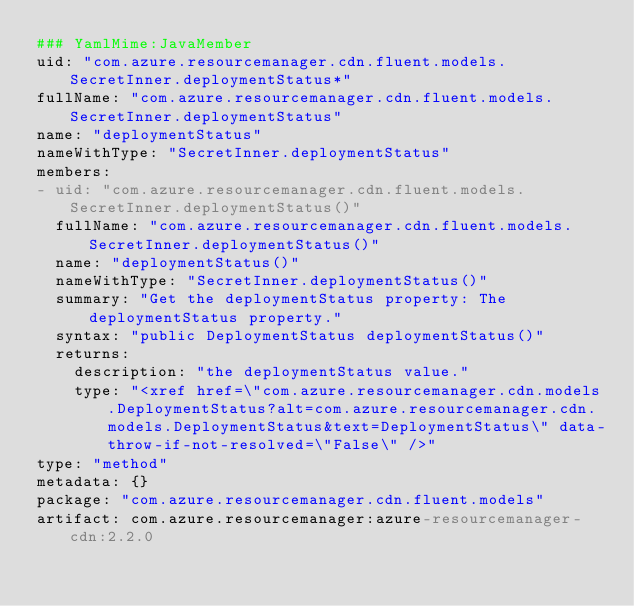<code> <loc_0><loc_0><loc_500><loc_500><_YAML_>### YamlMime:JavaMember
uid: "com.azure.resourcemanager.cdn.fluent.models.SecretInner.deploymentStatus*"
fullName: "com.azure.resourcemanager.cdn.fluent.models.SecretInner.deploymentStatus"
name: "deploymentStatus"
nameWithType: "SecretInner.deploymentStatus"
members:
- uid: "com.azure.resourcemanager.cdn.fluent.models.SecretInner.deploymentStatus()"
  fullName: "com.azure.resourcemanager.cdn.fluent.models.SecretInner.deploymentStatus()"
  name: "deploymentStatus()"
  nameWithType: "SecretInner.deploymentStatus()"
  summary: "Get the deploymentStatus property: The deploymentStatus property."
  syntax: "public DeploymentStatus deploymentStatus()"
  returns:
    description: "the deploymentStatus value."
    type: "<xref href=\"com.azure.resourcemanager.cdn.models.DeploymentStatus?alt=com.azure.resourcemanager.cdn.models.DeploymentStatus&text=DeploymentStatus\" data-throw-if-not-resolved=\"False\" />"
type: "method"
metadata: {}
package: "com.azure.resourcemanager.cdn.fluent.models"
artifact: com.azure.resourcemanager:azure-resourcemanager-cdn:2.2.0
</code> 